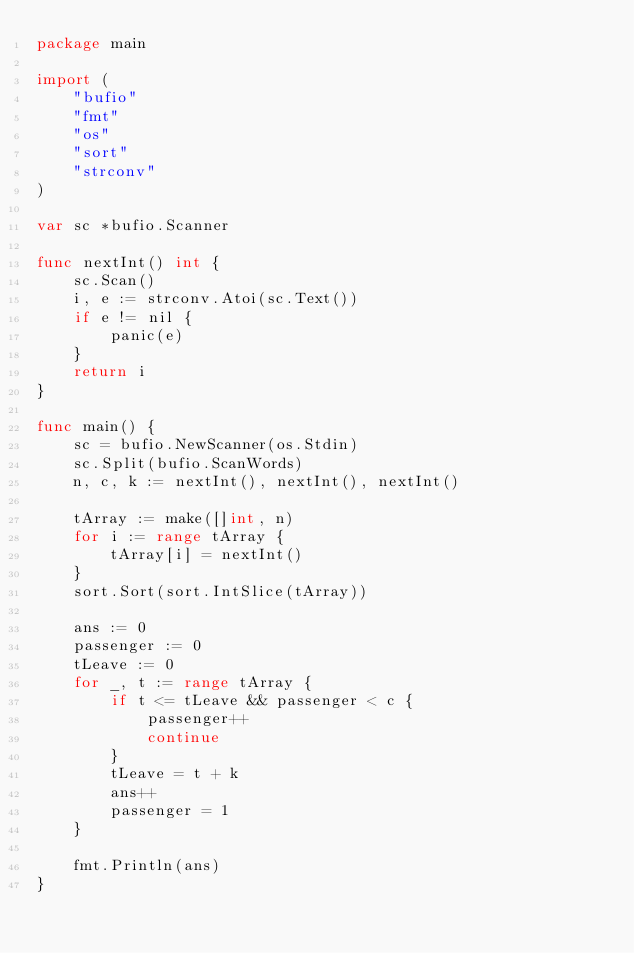<code> <loc_0><loc_0><loc_500><loc_500><_Go_>package main

import (
	"bufio"
	"fmt"
	"os"
	"sort"
	"strconv"
)

var sc *bufio.Scanner

func nextInt() int {
	sc.Scan()
	i, e := strconv.Atoi(sc.Text())
	if e != nil {
		panic(e)
	}
	return i
}

func main() {
	sc = bufio.NewScanner(os.Stdin)
	sc.Split(bufio.ScanWords)
	n, c, k := nextInt(), nextInt(), nextInt()

	tArray := make([]int, n)
	for i := range tArray {
		tArray[i] = nextInt()
	}
	sort.Sort(sort.IntSlice(tArray))

	ans := 0
	passenger := 0
	tLeave := 0
	for _, t := range tArray {
		if t <= tLeave && passenger < c {
			passenger++
			continue
		}
		tLeave = t + k
		ans++
		passenger = 1
	}

	fmt.Println(ans)
}
</code> 